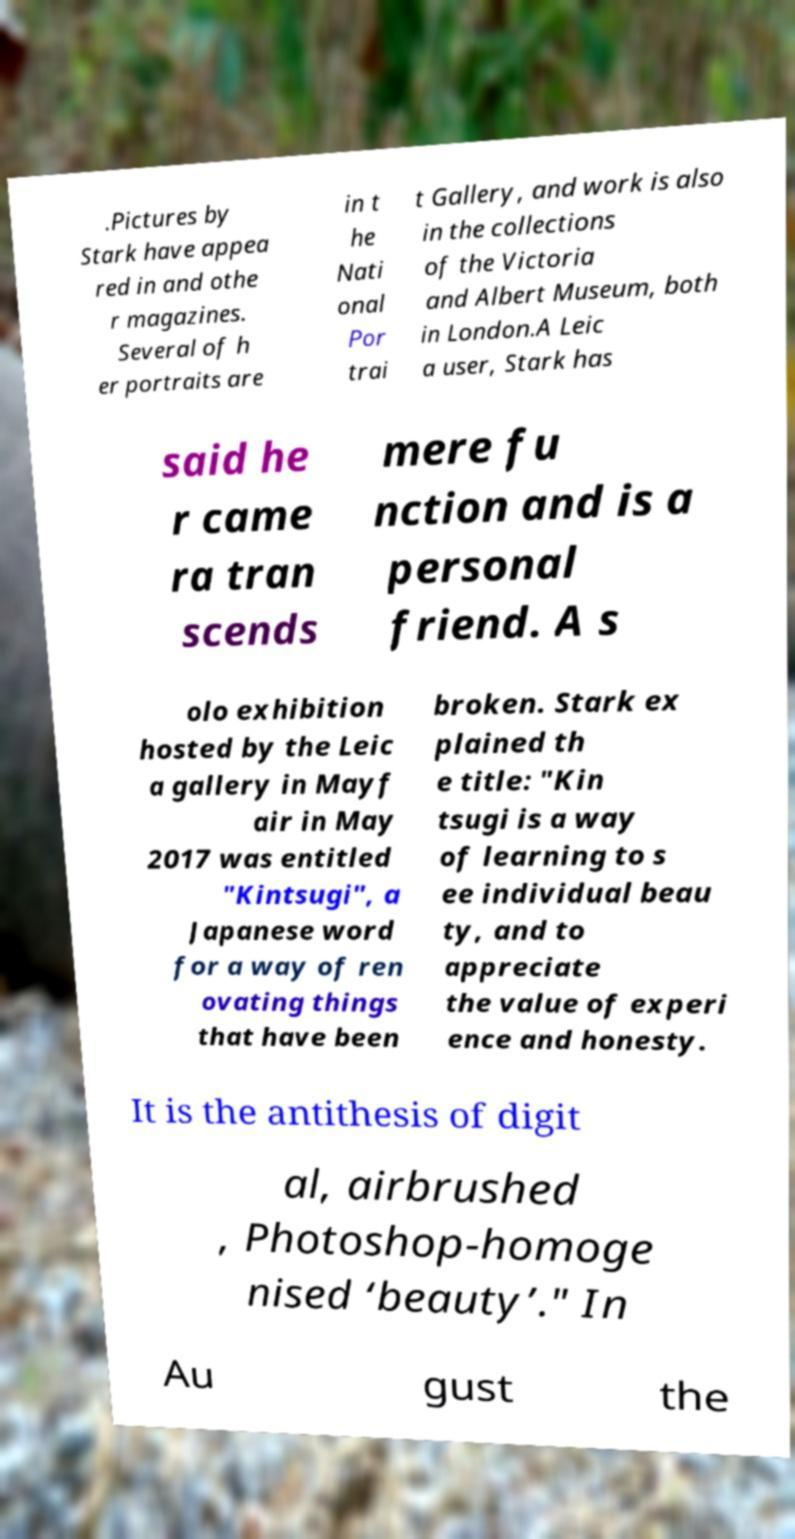Could you extract and type out the text from this image? .Pictures by Stark have appea red in and othe r magazines. Several of h er portraits are in t he Nati onal Por trai t Gallery, and work is also in the collections of the Victoria and Albert Museum, both in London.A Leic a user, Stark has said he r came ra tran scends mere fu nction and is a personal friend. A s olo exhibition hosted by the Leic a gallery in Mayf air in May 2017 was entitled "Kintsugi", a Japanese word for a way of ren ovating things that have been broken. Stark ex plained th e title: "Kin tsugi is a way of learning to s ee individual beau ty, and to appreciate the value of experi ence and honesty. It is the antithesis of digit al, airbrushed , Photoshop-homoge nised ‘beauty’." In Au gust the 